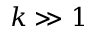Convert formula to latex. <formula><loc_0><loc_0><loc_500><loc_500>k \gg 1</formula> 